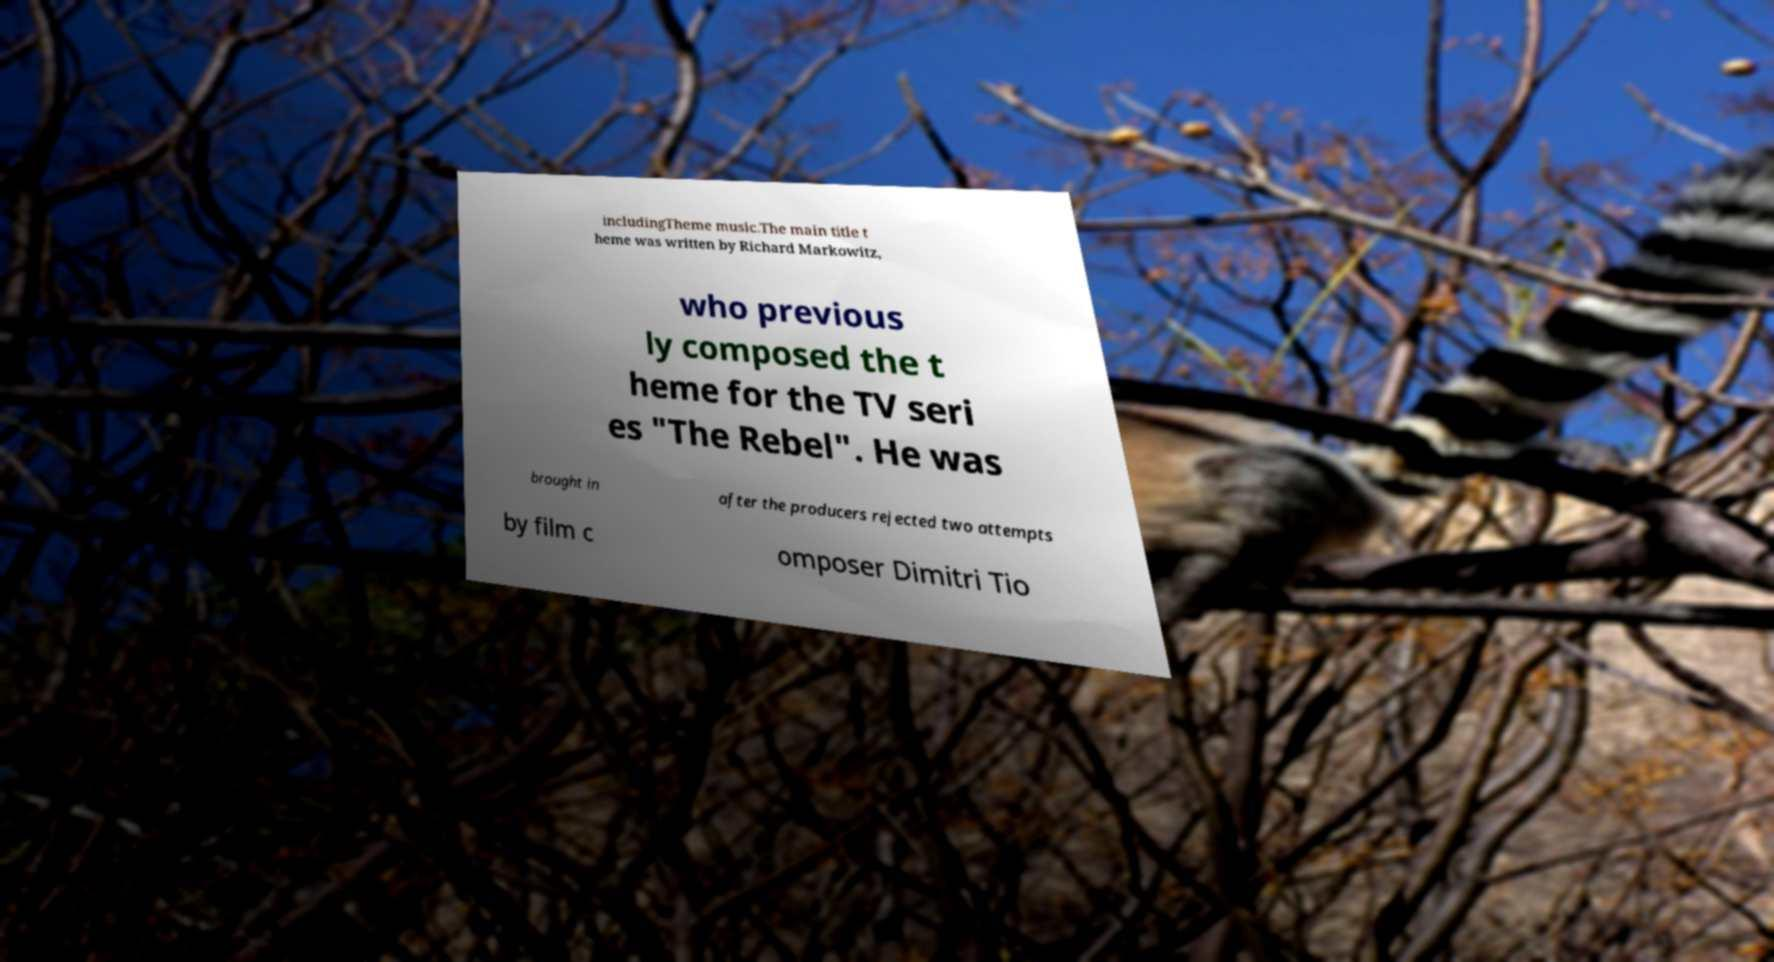For documentation purposes, I need the text within this image transcribed. Could you provide that? includingTheme music.The main title t heme was written by Richard Markowitz, who previous ly composed the t heme for the TV seri es "The Rebel". He was brought in after the producers rejected two attempts by film c omposer Dimitri Tio 